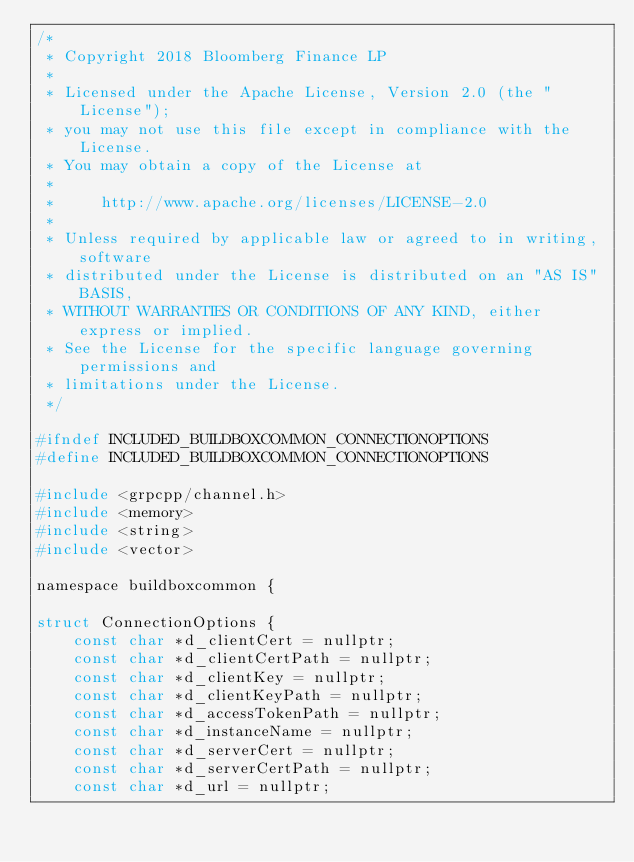Convert code to text. <code><loc_0><loc_0><loc_500><loc_500><_C_>/*
 * Copyright 2018 Bloomberg Finance LP
 *
 * Licensed under the Apache License, Version 2.0 (the "License");
 * you may not use this file except in compliance with the License.
 * You may obtain a copy of the License at
 *
 *     http://www.apache.org/licenses/LICENSE-2.0
 *
 * Unless required by applicable law or agreed to in writing, software
 * distributed under the License is distributed on an "AS IS" BASIS,
 * WITHOUT WARRANTIES OR CONDITIONS OF ANY KIND, either express or implied.
 * See the License for the specific language governing permissions and
 * limitations under the License.
 */

#ifndef INCLUDED_BUILDBOXCOMMON_CONNECTIONOPTIONS
#define INCLUDED_BUILDBOXCOMMON_CONNECTIONOPTIONS

#include <grpcpp/channel.h>
#include <memory>
#include <string>
#include <vector>

namespace buildboxcommon {

struct ConnectionOptions {
    const char *d_clientCert = nullptr;
    const char *d_clientCertPath = nullptr;
    const char *d_clientKey = nullptr;
    const char *d_clientKeyPath = nullptr;
    const char *d_accessTokenPath = nullptr;
    const char *d_instanceName = nullptr;
    const char *d_serverCert = nullptr;
    const char *d_serverCertPath = nullptr;
    const char *d_url = nullptr;</code> 